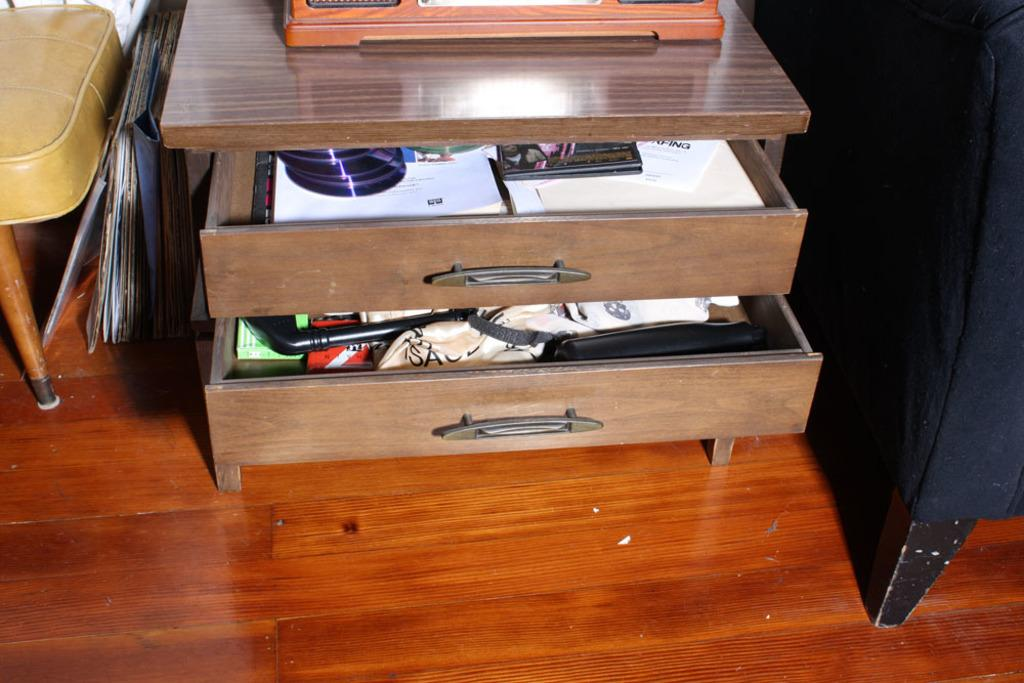What piece of furniture is present in the image? There is a table in the image. Where is the table located? The table is on the floor. How many drawers does the table have? The table has 2 drawers. What can be seen on the table? There are many things on the table. What is located to the left of the table? There is a chair to the left of the table. What items are near the table? There are files near the table. What time of day is it in the image, and is there a fireman present? The time of day cannot be determined from the image, and there is no fireman present. What type of watch can be seen on the table in the image? There is no watch visible on the table in the image. 